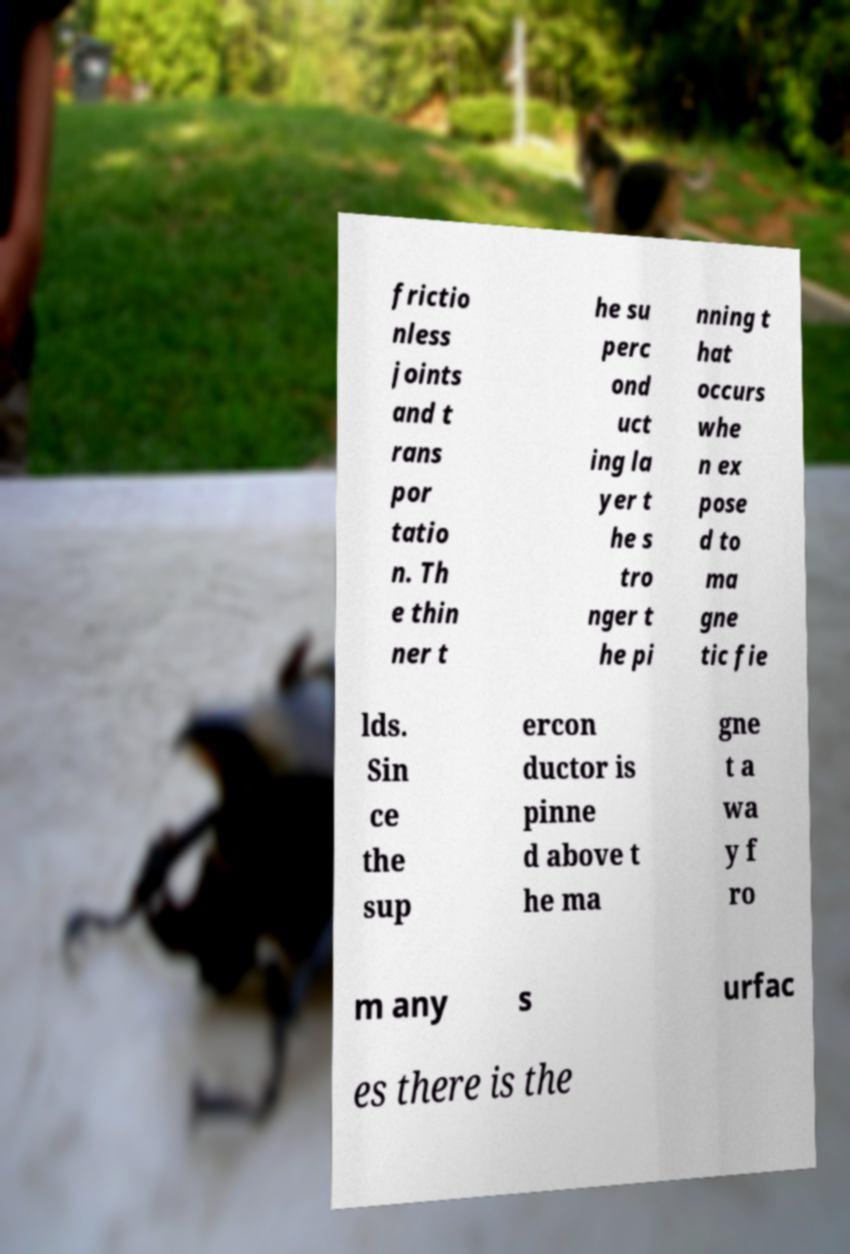Please read and relay the text visible in this image. What does it say? frictio nless joints and t rans por tatio n. Th e thin ner t he su perc ond uct ing la yer t he s tro nger t he pi nning t hat occurs whe n ex pose d to ma gne tic fie lds. Sin ce the sup ercon ductor is pinne d above t he ma gne t a wa y f ro m any s urfac es there is the 